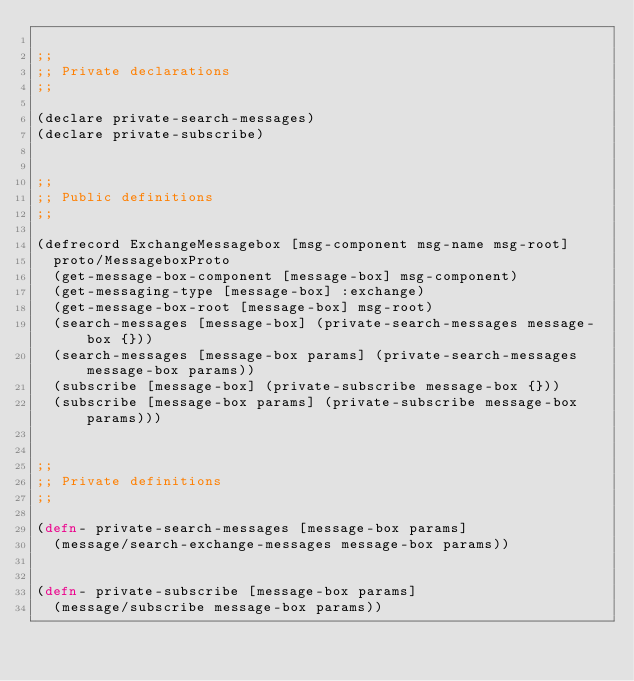<code> <loc_0><loc_0><loc_500><loc_500><_Clojure_>
;;
;; Private declarations
;;

(declare private-search-messages)
(declare private-subscribe)


;;
;; Public definitions
;;

(defrecord ExchangeMessagebox [msg-component msg-name msg-root]
  proto/MessageboxProto
  (get-message-box-component [message-box] msg-component)
  (get-messaging-type [message-box] :exchange)
  (get-message-box-root [message-box] msg-root)
  (search-messages [message-box] (private-search-messages message-box {}))
  (search-messages [message-box params] (private-search-messages message-box params))
  (subscribe [message-box] (private-subscribe message-box {}))
  (subscribe [message-box params] (private-subscribe message-box params)))


;;
;; Private definitions
;;

(defn- private-search-messages [message-box params]
  (message/search-exchange-messages message-box params))


(defn- private-subscribe [message-box params]
  (message/subscribe message-box params))
</code> 